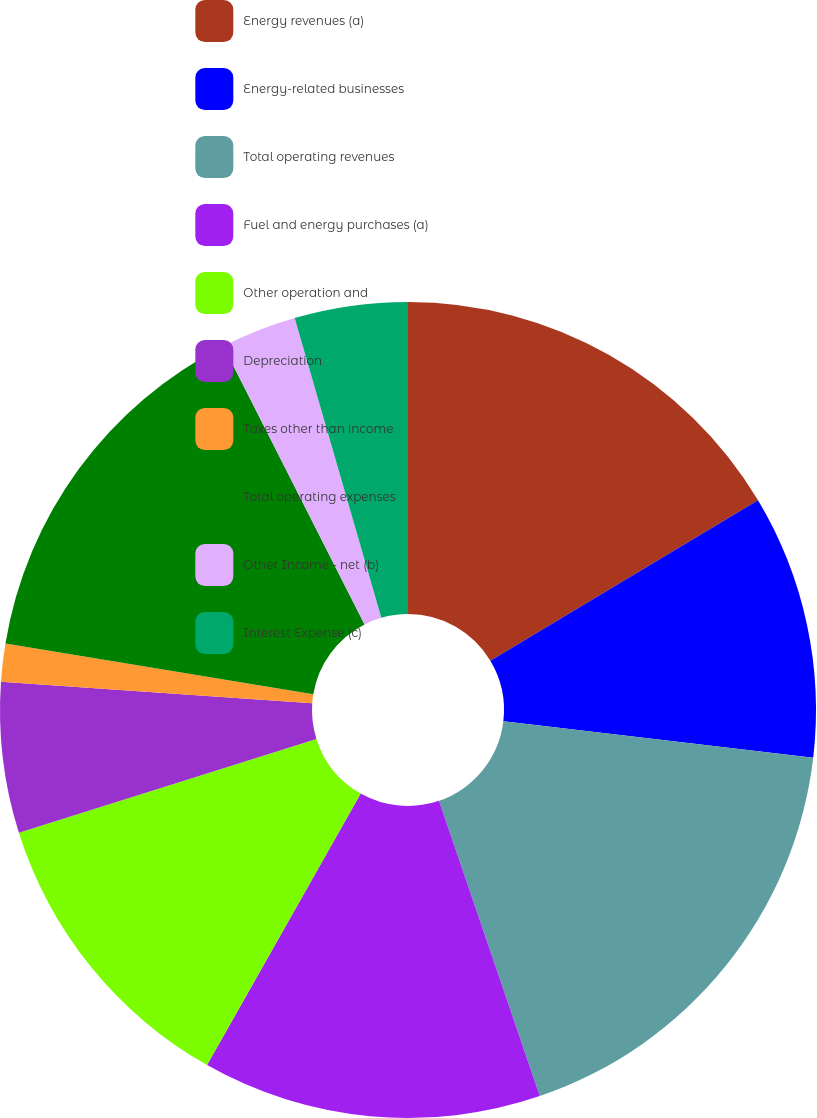Convert chart to OTSL. <chart><loc_0><loc_0><loc_500><loc_500><pie_chart><fcel>Energy revenues (a)<fcel>Energy-related businesses<fcel>Total operating revenues<fcel>Fuel and energy purchases (a)<fcel>Other operation and<fcel>Depreciation<fcel>Taxes other than income<fcel>Total operating expenses<fcel>Other Income - net (b)<fcel>Interest Expense (c)<nl><fcel>16.41%<fcel>10.45%<fcel>17.9%<fcel>13.43%<fcel>11.94%<fcel>5.97%<fcel>1.5%<fcel>14.92%<fcel>2.99%<fcel>4.48%<nl></chart> 